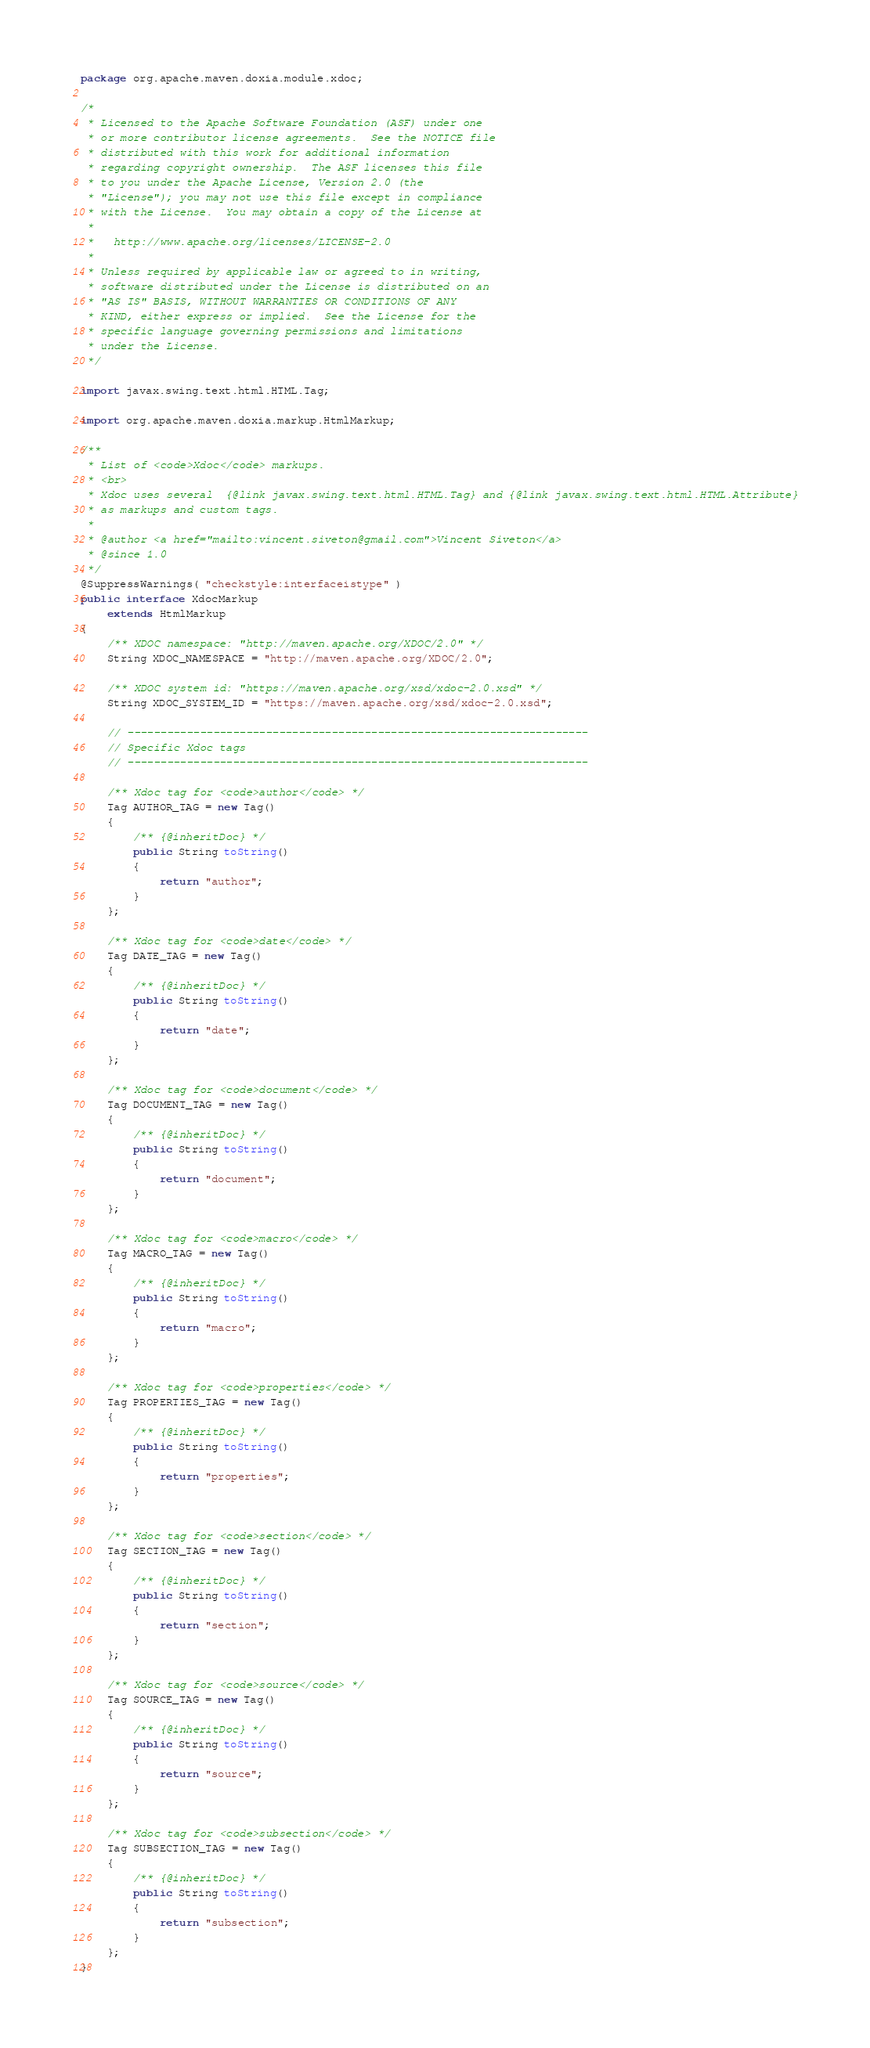<code> <loc_0><loc_0><loc_500><loc_500><_Java_>package org.apache.maven.doxia.module.xdoc;

/*
 * Licensed to the Apache Software Foundation (ASF) under one
 * or more contributor license agreements.  See the NOTICE file
 * distributed with this work for additional information
 * regarding copyright ownership.  The ASF licenses this file
 * to you under the Apache License, Version 2.0 (the
 * "License"); you may not use this file except in compliance
 * with the License.  You may obtain a copy of the License at
 *
 *   http://www.apache.org/licenses/LICENSE-2.0
 *
 * Unless required by applicable law or agreed to in writing,
 * software distributed under the License is distributed on an
 * "AS IS" BASIS, WITHOUT WARRANTIES OR CONDITIONS OF ANY
 * KIND, either express or implied.  See the License for the
 * specific language governing permissions and limitations
 * under the License.
 */

import javax.swing.text.html.HTML.Tag;

import org.apache.maven.doxia.markup.HtmlMarkup;

/**
 * List of <code>Xdoc</code> markups.
 * <br>
 * Xdoc uses several  {@link javax.swing.text.html.HTML.Tag} and {@link javax.swing.text.html.HTML.Attribute}
 * as markups and custom tags.
 *
 * @author <a href="mailto:vincent.siveton@gmail.com">Vincent Siveton</a>
 * @since 1.0
 */
@SuppressWarnings( "checkstyle:interfaceistype" )
public interface XdocMarkup
    extends HtmlMarkup
{
    /** XDOC namespace: "http://maven.apache.org/XDOC/2.0" */
    String XDOC_NAMESPACE = "http://maven.apache.org/XDOC/2.0";

    /** XDOC system id: "https://maven.apache.org/xsd/xdoc-2.0.xsd" */
    String XDOC_SYSTEM_ID = "https://maven.apache.org/xsd/xdoc-2.0.xsd";

    // ----------------------------------------------------------------------
    // Specific Xdoc tags
    // ----------------------------------------------------------------------

    /** Xdoc tag for <code>author</code> */
    Tag AUTHOR_TAG = new Tag()
    {
        /** {@inheritDoc} */
        public String toString()
        {
            return "author";
        }
    };

    /** Xdoc tag for <code>date</code> */
    Tag DATE_TAG = new Tag()
    {
        /** {@inheritDoc} */
        public String toString()
        {
            return "date";
        }
    };

    /** Xdoc tag for <code>document</code> */
    Tag DOCUMENT_TAG = new Tag()
    {
        /** {@inheritDoc} */
        public String toString()
        {
            return "document";
        }
    };

    /** Xdoc tag for <code>macro</code> */
    Tag MACRO_TAG = new Tag()
    {
        /** {@inheritDoc} */
        public String toString()
        {
            return "macro";
        }
    };

    /** Xdoc tag for <code>properties</code> */
    Tag PROPERTIES_TAG = new Tag()
    {
        /** {@inheritDoc} */
        public String toString()
        {
            return "properties";
        }
    };

    /** Xdoc tag for <code>section</code> */
    Tag SECTION_TAG = new Tag()
    {
        /** {@inheritDoc} */
        public String toString()
        {
            return "section";
        }
    };

    /** Xdoc tag for <code>source</code> */
    Tag SOURCE_TAG = new Tag()
    {
        /** {@inheritDoc} */
        public String toString()
        {
            return "source";
        }
    };

    /** Xdoc tag for <code>subsection</code> */
    Tag SUBSECTION_TAG = new Tag()
    {
        /** {@inheritDoc} */
        public String toString()
        {
            return "subsection";
        }
    };
}
</code> 